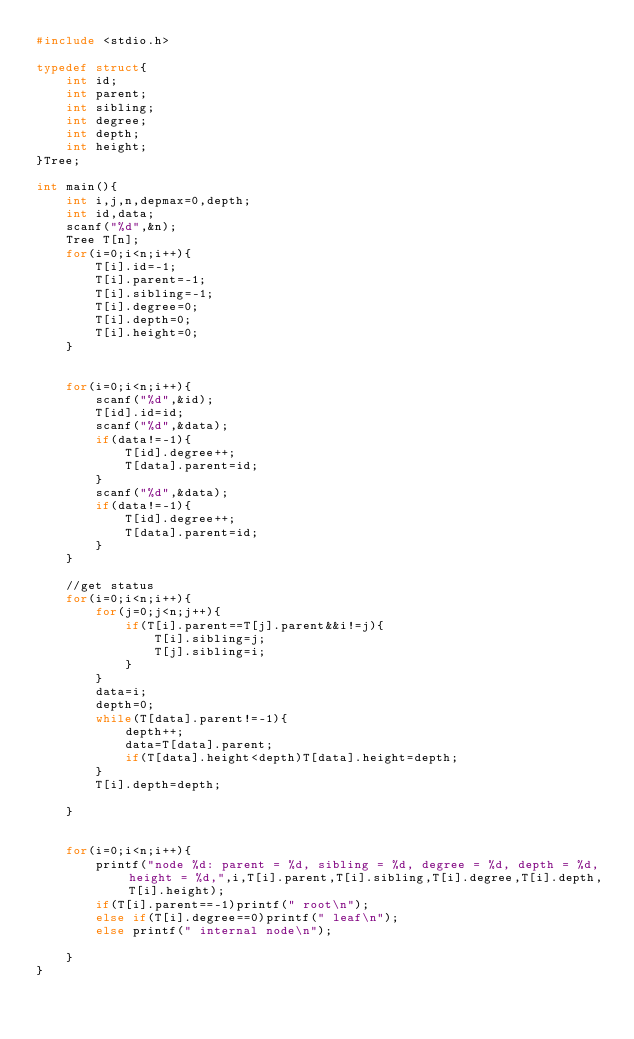Convert code to text. <code><loc_0><loc_0><loc_500><loc_500><_C_>#include <stdio.h>

typedef struct{
    int id;
    int parent;
    int sibling;
    int degree;
    int depth;
    int height;
}Tree;

int main(){
    int i,j,n,depmax=0,depth;
    int id,data;
    scanf("%d",&n);
    Tree T[n];
    for(i=0;i<n;i++){
        T[i].id=-1;
        T[i].parent=-1;
        T[i].sibling=-1;
        T[i].degree=0;
        T[i].depth=0;
        T[i].height=0;
    }
    
    
    for(i=0;i<n;i++){
        scanf("%d",&id);
        T[id].id=id;
        scanf("%d",&data);
        if(data!=-1){
            T[id].degree++;
            T[data].parent=id;
        }
        scanf("%d",&data);
        if(data!=-1){
            T[id].degree++;
            T[data].parent=id;
        }
    }
    
    //get status
    for(i=0;i<n;i++){
        for(j=0;j<n;j++){
            if(T[i].parent==T[j].parent&&i!=j){
                T[i].sibling=j;
                T[j].sibling=i;
            }
        }
        data=i;
        depth=0;
        while(T[data].parent!=-1){
            depth++;
            data=T[data].parent;
            if(T[data].height<depth)T[data].height=depth;
        }
        T[i].depth=depth;
        
    }
    
    
    for(i=0;i<n;i++){
        printf("node %d: parent = %d, sibling = %d, degree = %d, depth = %d, height = %d,",i,T[i].parent,T[i].sibling,T[i].degree,T[i].depth,T[i].height);
        if(T[i].parent==-1)printf(" root\n");
        else if(T[i].degree==0)printf(" leaf\n");
        else printf(" internal node\n");
        
    }
}</code> 